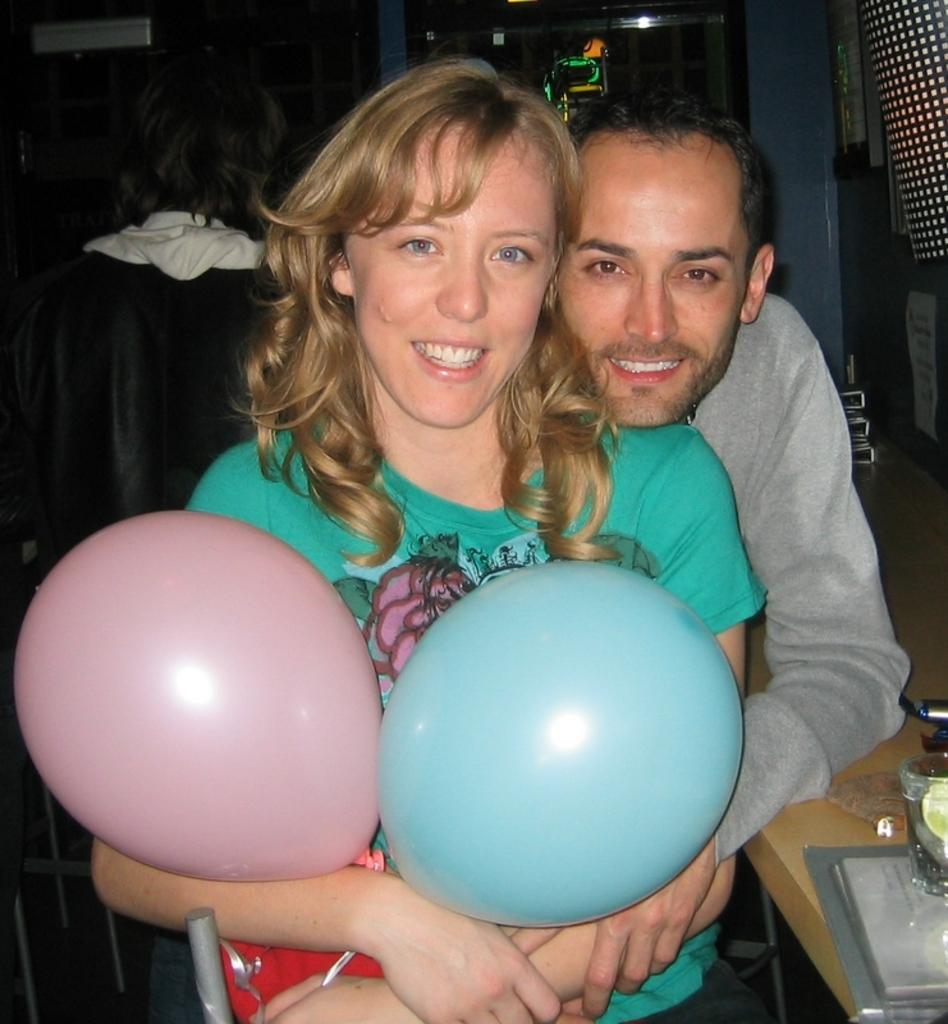Who is present in the image? There is a man in the image. What is the man doing in the image? The man is holding a woman in the image. What decorative items can be seen in the image? There are balloons in the image. What objects are on the table in the image? There are objects on a table in the image. What type of train can be seen passing by on the street in the image? There is no train or street present in the image; it features a man holding a woman with balloons and objects on a table. 